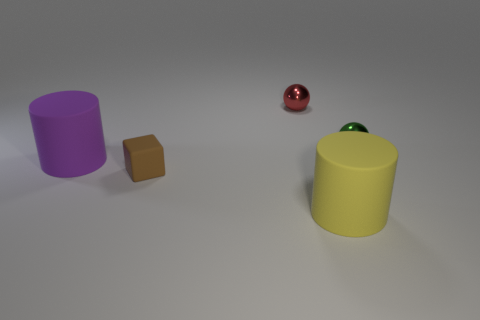Add 3 small metallic things. How many objects exist? 8 Subtract all blocks. How many objects are left? 4 Add 5 yellow rubber cylinders. How many yellow rubber cylinders exist? 6 Subtract 0 brown cylinders. How many objects are left? 5 Subtract all green balls. Subtract all small cubes. How many objects are left? 3 Add 4 blocks. How many blocks are left? 5 